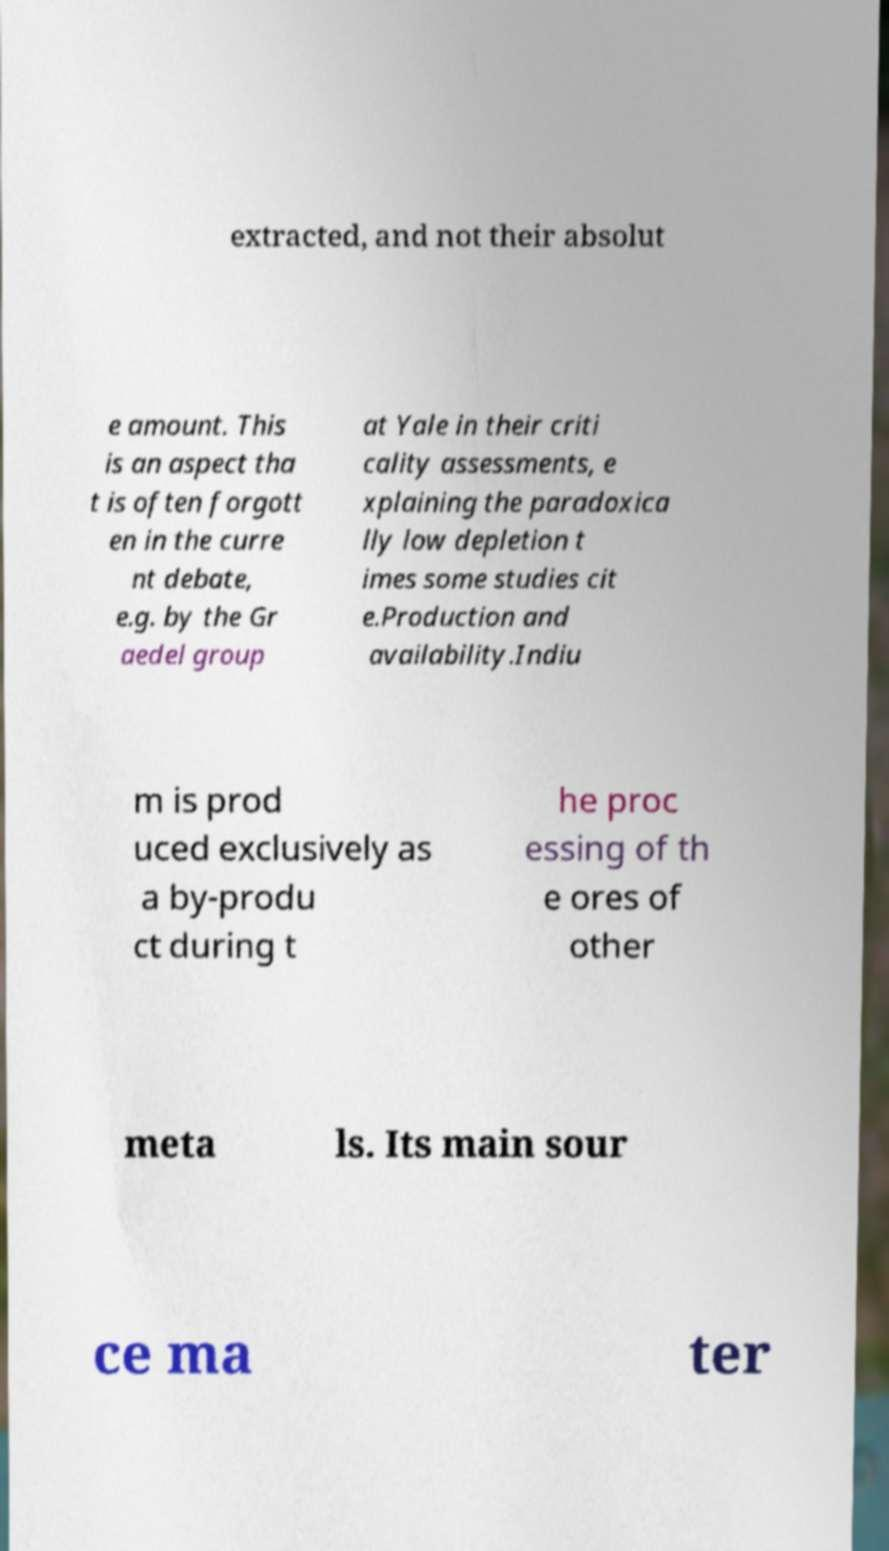Could you assist in decoding the text presented in this image and type it out clearly? extracted, and not their absolut e amount. This is an aspect tha t is often forgott en in the curre nt debate, e.g. by the Gr aedel group at Yale in their criti cality assessments, e xplaining the paradoxica lly low depletion t imes some studies cit e.Production and availability.Indiu m is prod uced exclusively as a by-produ ct during t he proc essing of th e ores of other meta ls. Its main sour ce ma ter 